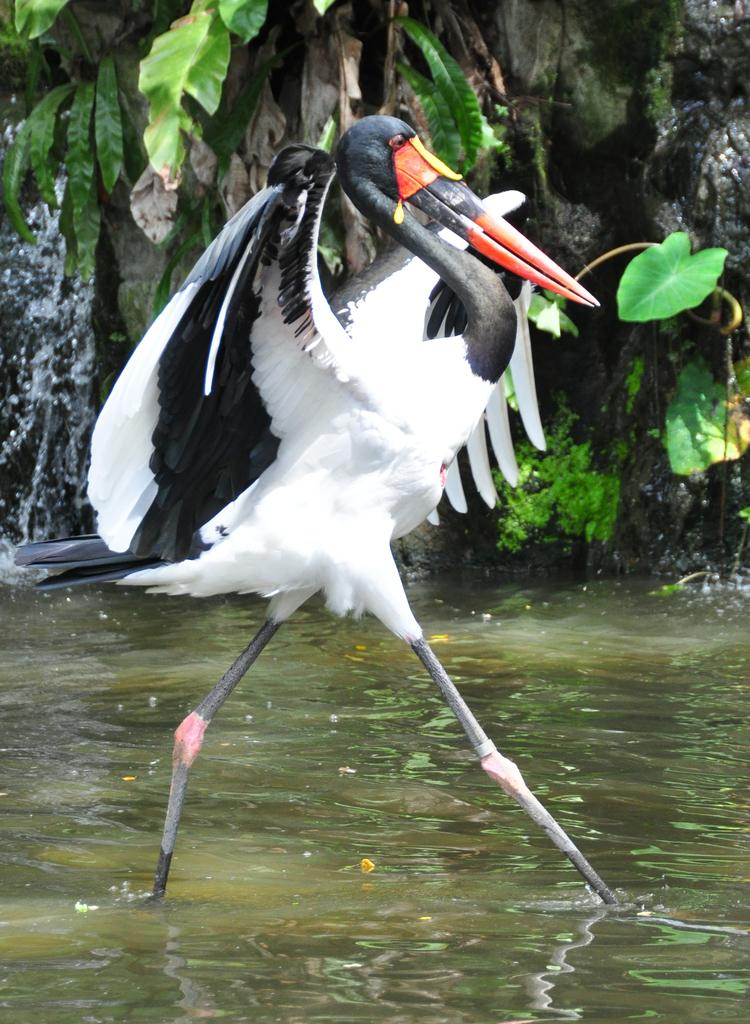What type of animal is in the image? There is a flamingo in the image. What colors can be seen on the flamingo? The flamingo is white and black in color. What is the flamingo doing in the image? The flamingo is walking in the water. What can be seen in the background of the image? There is a tree visible in the background of the image. Can you see the flamingo's self in the water? There is no indication of a reflection or self in the water in the image. 